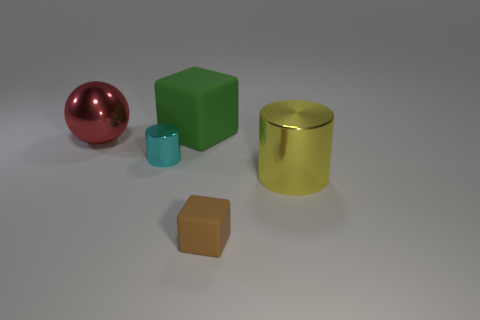What materials do the objects in the image seem to be made from? The objects exhibit different materials: the red sphere has a reflective metallic finish, the green cube looks like matte plastic, the cyan cylinder has a glossy reflective surface, the yellow cylinder appears semi-reflective and could be metal or plastic, and the brown cube also looks matte, potentially a different type of plastic or wood. 